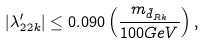<formula> <loc_0><loc_0><loc_500><loc_500>| \lambda ^ { \prime } _ { 2 2 k } | \leq 0 . 0 9 0 \left ( \frac { m _ { \tilde { d } _ { R k } } } { 1 0 0 G e V } \right ) ,</formula> 